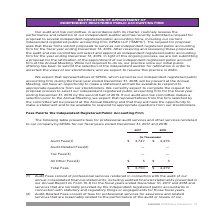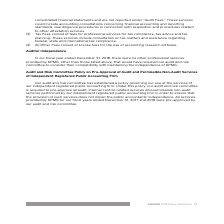According to Square's financial document, What does “All Other Fees” consist of? License fees for the use of accounting research software. The document states: "nal tax compliance. (4) All Other Fees consist of license fees for the use of accounting research software...." Also, What does “Tax Fees” consist of? Fees for professional services for tax compliance, tax advice and tax planning. The document states: "her attestation services. (3) Tax Fees consist of fees for professional services for tax compliance, tax advice and tax planning. These services inclu..." Also, Which firm does the company hire for professional audit services and other services? According to the financial document, KPMG. The relevant text states: "nt independent registered public accounting firm, KPMG LLP (“KMPG”). The request for proposal asks that these firms submit proposals to serve as our indep..." Also, can you calculate: What is the average total fees paid to KPMG from 2017 to 2018? To answer this question, I need to perform calculations using the financial data. The calculation is: (3,750 + 4,479) / 2 , which equals 4114.5 (in thousands). This is based on the information: "Total Fees $ 3,750 $ 4,479 Total Fees $ 3,750 $ 4,479..." The key data points involved are: 3,750, 4,479. Also, can you calculate: What is the percentage change of the Audit fees from 2017 to 2018? To answer this question, I need to perform calculations using the financial data. The calculation is: (4,476 - 3,747) / 3,747 , which equals 19.46 (percentage). This is based on the information: "(In Thousands) Audit Fees(1) $ 3,747 $ 4,476 (In Thousands) Audit Fees(1) $ 3,747 $ 4,476..." The key data points involved are: 3,747, 4,476. Also, can you calculate: What is the change of “All Other Fees” from 2017 to 2018? I cannot find a specific answer to this question in the financial document. 